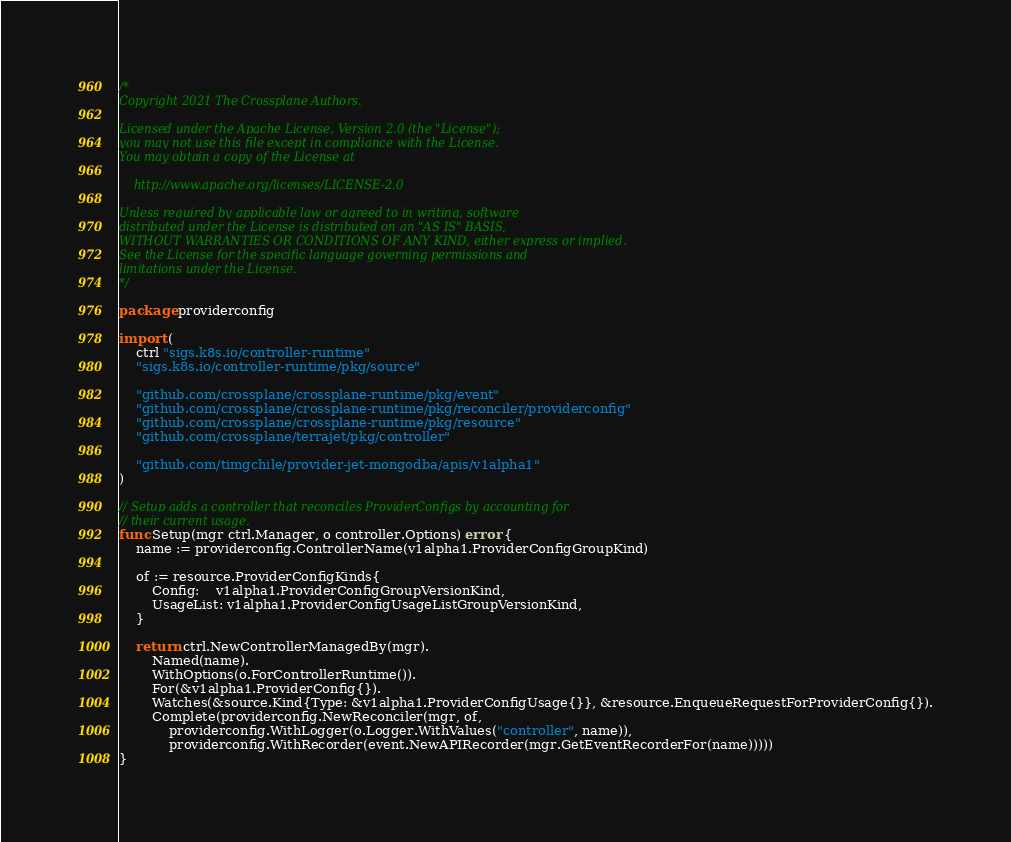Convert code to text. <code><loc_0><loc_0><loc_500><loc_500><_Go_>/*
Copyright 2021 The Crossplane Authors.

Licensed under the Apache License, Version 2.0 (the "License");
you may not use this file except in compliance with the License.
You may obtain a copy of the License at

    http://www.apache.org/licenses/LICENSE-2.0

Unless required by applicable law or agreed to in writing, software
distributed under the License is distributed on an "AS IS" BASIS,
WITHOUT WARRANTIES OR CONDITIONS OF ANY KIND, either express or implied.
See the License for the specific language governing permissions and
limitations under the License.
*/

package providerconfig

import (
	ctrl "sigs.k8s.io/controller-runtime"
	"sigs.k8s.io/controller-runtime/pkg/source"

	"github.com/crossplane/crossplane-runtime/pkg/event"
	"github.com/crossplane/crossplane-runtime/pkg/reconciler/providerconfig"
	"github.com/crossplane/crossplane-runtime/pkg/resource"
	"github.com/crossplane/terrajet/pkg/controller"

	"github.com/timgchile/provider-jet-mongodba/apis/v1alpha1"
)

// Setup adds a controller that reconciles ProviderConfigs by accounting for
// their current usage.
func Setup(mgr ctrl.Manager, o controller.Options) error {
	name := providerconfig.ControllerName(v1alpha1.ProviderConfigGroupKind)

	of := resource.ProviderConfigKinds{
		Config:    v1alpha1.ProviderConfigGroupVersionKind,
		UsageList: v1alpha1.ProviderConfigUsageListGroupVersionKind,
	}

	return ctrl.NewControllerManagedBy(mgr).
		Named(name).
		WithOptions(o.ForControllerRuntime()).
		For(&v1alpha1.ProviderConfig{}).
		Watches(&source.Kind{Type: &v1alpha1.ProviderConfigUsage{}}, &resource.EnqueueRequestForProviderConfig{}).
		Complete(providerconfig.NewReconciler(mgr, of,
			providerconfig.WithLogger(o.Logger.WithValues("controller", name)),
			providerconfig.WithRecorder(event.NewAPIRecorder(mgr.GetEventRecorderFor(name)))))
}
</code> 